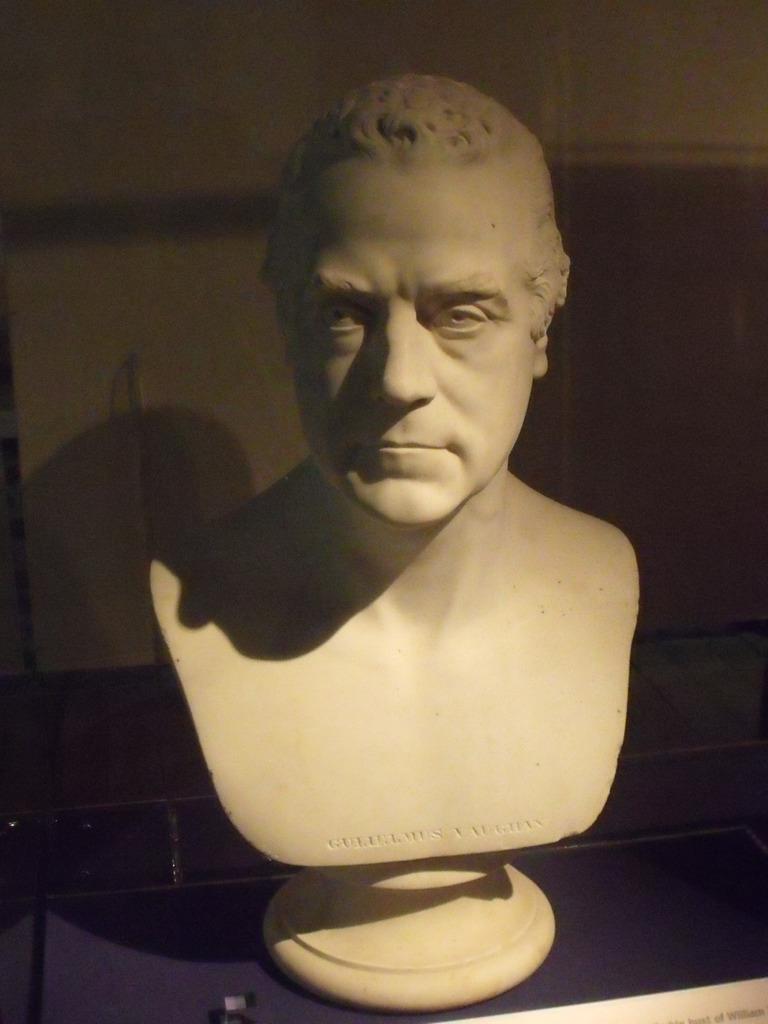Can you describe this image briefly? In this image there is a statue. 